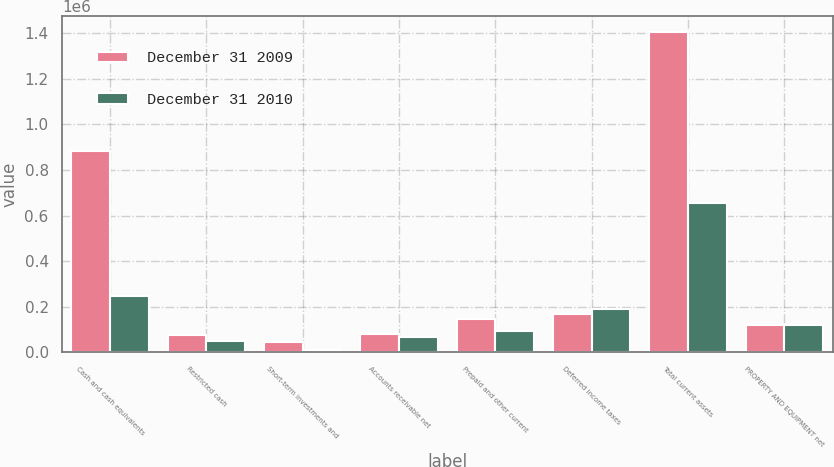<chart> <loc_0><loc_0><loc_500><loc_500><stacked_bar_chart><ecel><fcel>Cash and cash equivalents<fcel>Restricted cash<fcel>Short-term investments and<fcel>Accounts receivable net<fcel>Prepaid and other current<fcel>Deferred income taxes<fcel>Total current assets<fcel>PROPERTY AND EQUIPMENT net<nl><fcel>December 31 2009<fcel>883963<fcel>75972<fcel>46428<fcel>80961<fcel>147843<fcel>169007<fcel>1.40417e+06<fcel>120317<nl><fcel>December 31 2010<fcel>247293<fcel>47836<fcel>9776<fcel>67949<fcel>92791<fcel>189451<fcel>655096<fcel>120317<nl></chart> 